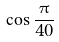<formula> <loc_0><loc_0><loc_500><loc_500>\cos \frac { \pi } { 4 0 }</formula> 